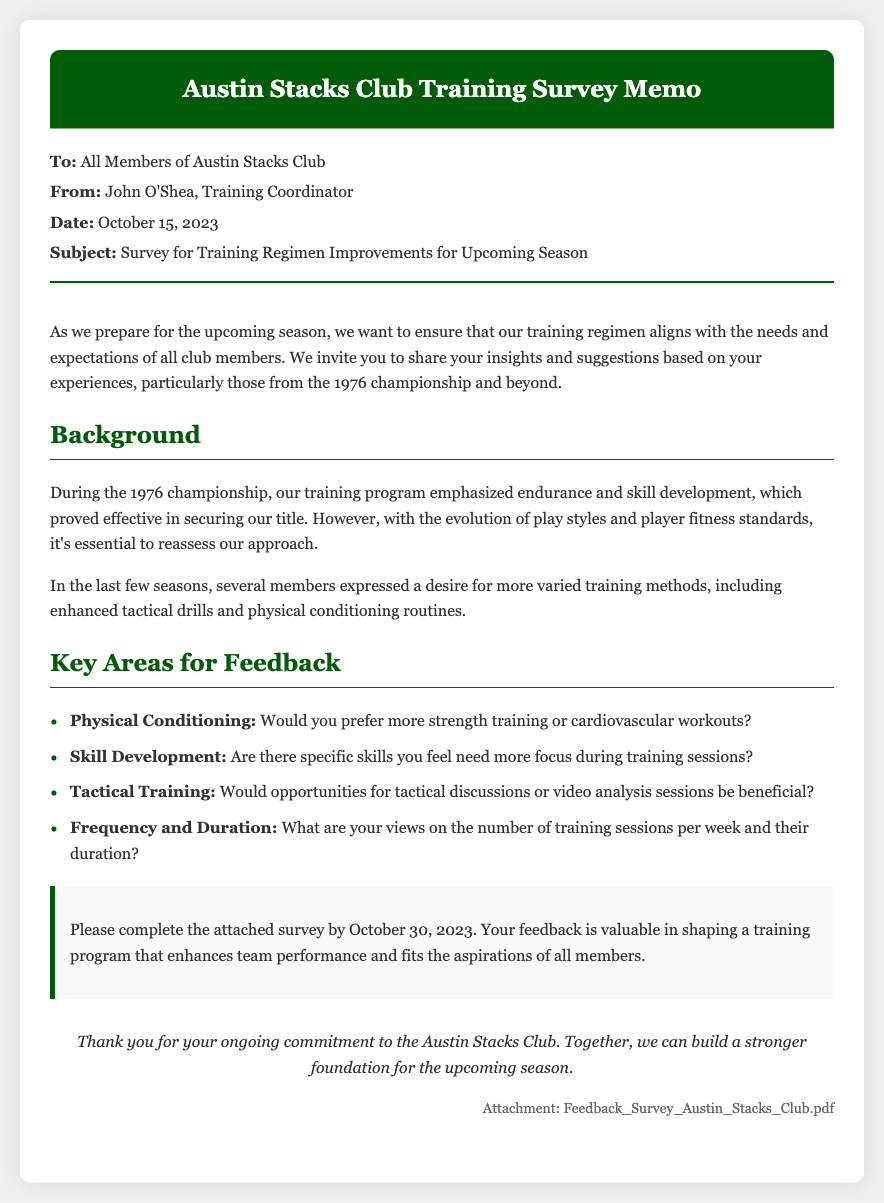What is the date of the memo? The date of the memo is stated in the document under the meta section.
Answer: October 15, 2023 Who is the sender of the memo? The sender's name appears in the meta section of the document.
Answer: John O'Shea What is the deadline for completing the survey? The deadline for the survey is mentioned in the call-to-action section.
Answer: October 30, 2023 What are the key areas for feedback mentioned? The document lists specific areas that members should provide feedback on, relevant to the training regimen.
Answer: Physical Conditioning, Skill Development, Tactical Training, Frequency and Duration What training aspect does the background emphasize? The background section discusses an aspect of training related to past successes, which is specified in the content.
Answer: Endurance and skill development How many key areas does the document identify for feedback? The number of key areas is specified in the 'Key Areas for Feedback' section.
Answer: Four What is the subject of the memo? The subject of the memo is clearly stated in the meta section of the document.
Answer: Survey for Training Regimen Improvements for Upcoming Season What document is attached to the memo? The attachment is mentioned in the memo, providing details on what members need to complete.
Answer: Feedback_Survey_Austin_Stacks_Club.pdf What focus is desired for the tactical training feedback? The memo asks for specific feedback regarding opportunities for tactical discussions, which indicates a certain focus.
Answer: Tactical discussions or video analysis sessions 